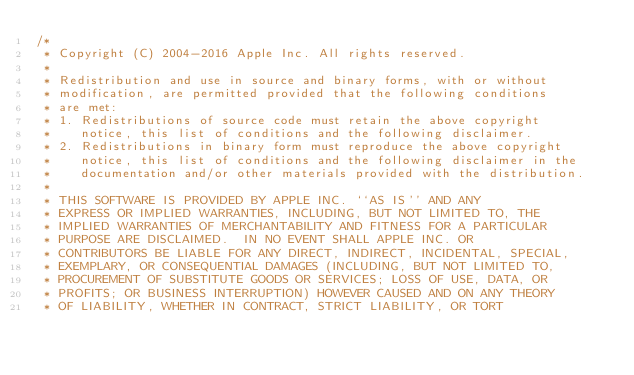Convert code to text. <code><loc_0><loc_0><loc_500><loc_500><_ObjectiveC_>/*
 * Copyright (C) 2004-2016 Apple Inc. All rights reserved.
 *
 * Redistribution and use in source and binary forms, with or without
 * modification, are permitted provided that the following conditions
 * are met:
 * 1. Redistributions of source code must retain the above copyright
 *    notice, this list of conditions and the following disclaimer.
 * 2. Redistributions in binary form must reproduce the above copyright
 *    notice, this list of conditions and the following disclaimer in the
 *    documentation and/or other materials provided with the distribution.
 *
 * THIS SOFTWARE IS PROVIDED BY APPLE INC. ``AS IS'' AND ANY
 * EXPRESS OR IMPLIED WARRANTIES, INCLUDING, BUT NOT LIMITED TO, THE
 * IMPLIED WARRANTIES OF MERCHANTABILITY AND FITNESS FOR A PARTICULAR
 * PURPOSE ARE DISCLAIMED.  IN NO EVENT SHALL APPLE INC. OR
 * CONTRIBUTORS BE LIABLE FOR ANY DIRECT, INDIRECT, INCIDENTAL, SPECIAL,
 * EXEMPLARY, OR CONSEQUENTIAL DAMAGES (INCLUDING, BUT NOT LIMITED TO,
 * PROCUREMENT OF SUBSTITUTE GOODS OR SERVICES; LOSS OF USE, DATA, OR
 * PROFITS; OR BUSINESS INTERRUPTION) HOWEVER CAUSED AND ON ANY THEORY
 * OF LIABILITY, WHETHER IN CONTRACT, STRICT LIABILITY, OR TORT</code> 